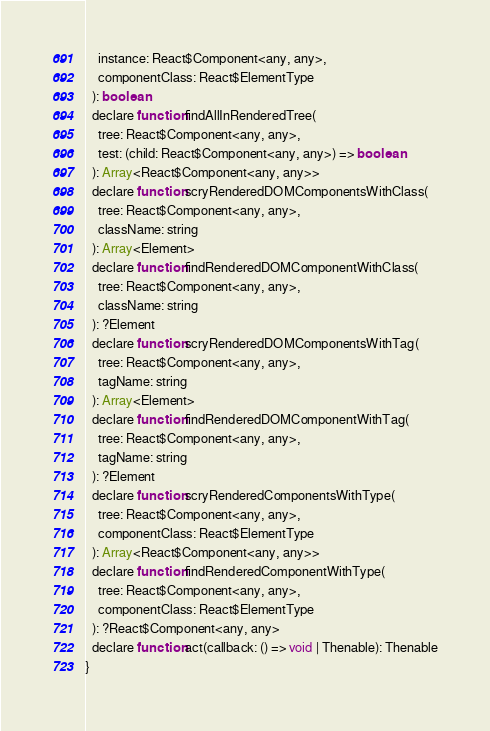Convert code to text. <code><loc_0><loc_0><loc_500><loc_500><_JavaScript_>    instance: React$Component<any, any>,
    componentClass: React$ElementType
  ): boolean
  declare function findAllInRenderedTree(
    tree: React$Component<any, any>,
    test: (child: React$Component<any, any>) => boolean
  ): Array<React$Component<any, any>>
  declare function scryRenderedDOMComponentsWithClass(
    tree: React$Component<any, any>,
    className: string
  ): Array<Element>
  declare function findRenderedDOMComponentWithClass(
    tree: React$Component<any, any>,
    className: string
  ): ?Element
  declare function scryRenderedDOMComponentsWithTag(
    tree: React$Component<any, any>,
    tagName: string
  ): Array<Element>
  declare function findRenderedDOMComponentWithTag(
    tree: React$Component<any, any>,
    tagName: string
  ): ?Element
  declare function scryRenderedComponentsWithType(
    tree: React$Component<any, any>,
    componentClass: React$ElementType
  ): Array<React$Component<any, any>>
  declare function findRenderedComponentWithType(
    tree: React$Component<any, any>,
    componentClass: React$ElementType
  ): ?React$Component<any, any>
  declare function act(callback: () => void | Thenable): Thenable
}
</code> 